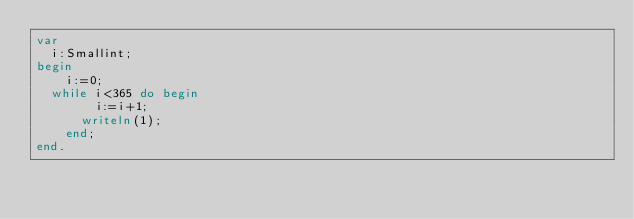<code> <loc_0><loc_0><loc_500><loc_500><_Pascal_>var
	i:Smallint;
begin
    i:=0;
	while i<365 do begin
        i:=i+1;
    	writeln(1);
    end;
end.</code> 